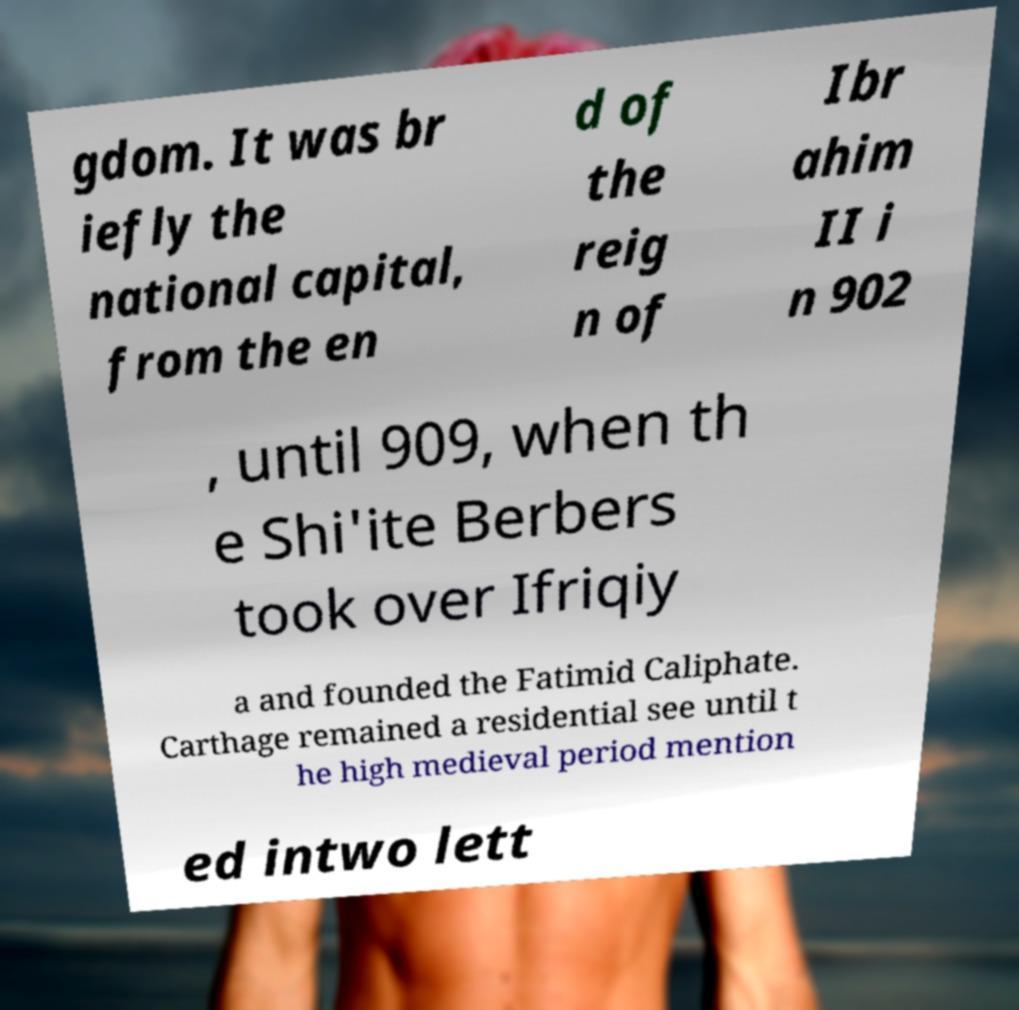What messages or text are displayed in this image? I need them in a readable, typed format. gdom. It was br iefly the national capital, from the en d of the reig n of Ibr ahim II i n 902 , until 909, when th e Shi'ite Berbers took over Ifriqiy a and founded the Fatimid Caliphate. Carthage remained a residential see until t he high medieval period mention ed intwo lett 